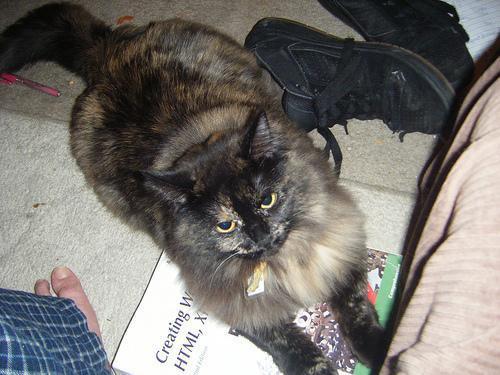How many cats are there?
Give a very brief answer. 1. 